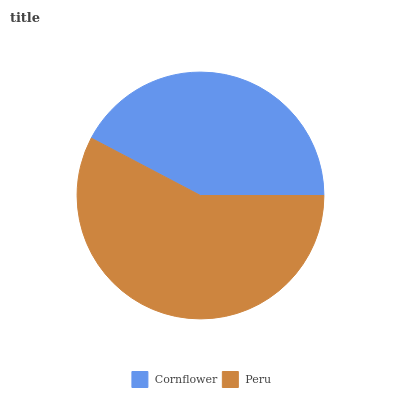Is Cornflower the minimum?
Answer yes or no. Yes. Is Peru the maximum?
Answer yes or no. Yes. Is Peru the minimum?
Answer yes or no. No. Is Peru greater than Cornflower?
Answer yes or no. Yes. Is Cornflower less than Peru?
Answer yes or no. Yes. Is Cornflower greater than Peru?
Answer yes or no. No. Is Peru less than Cornflower?
Answer yes or no. No. Is Peru the high median?
Answer yes or no. Yes. Is Cornflower the low median?
Answer yes or no. Yes. Is Cornflower the high median?
Answer yes or no. No. Is Peru the low median?
Answer yes or no. No. 